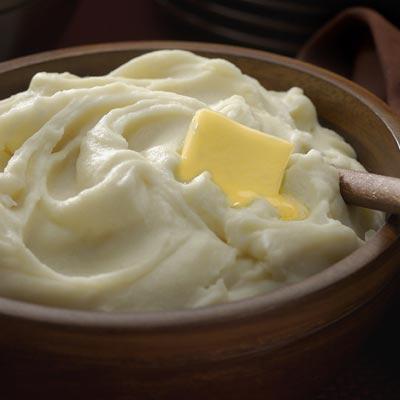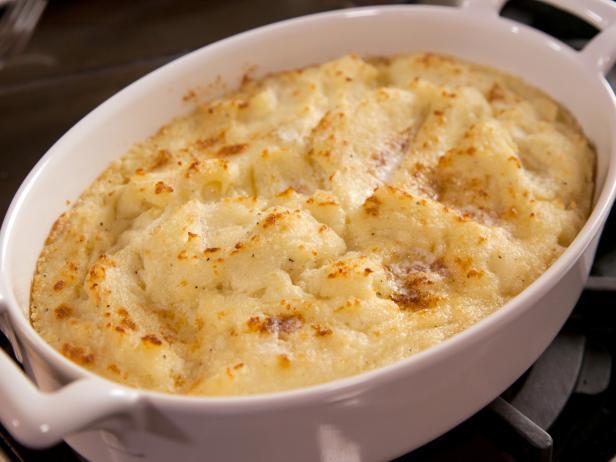The first image is the image on the left, the second image is the image on the right. For the images displayed, is the sentence "An image shows a bowl of potatoes with handle of a utensil sticking out." factually correct? Answer yes or no. Yes. The first image is the image on the left, the second image is the image on the right. For the images displayed, is the sentence "A vegetable is visible in one of the images." factually correct? Answer yes or no. No. 